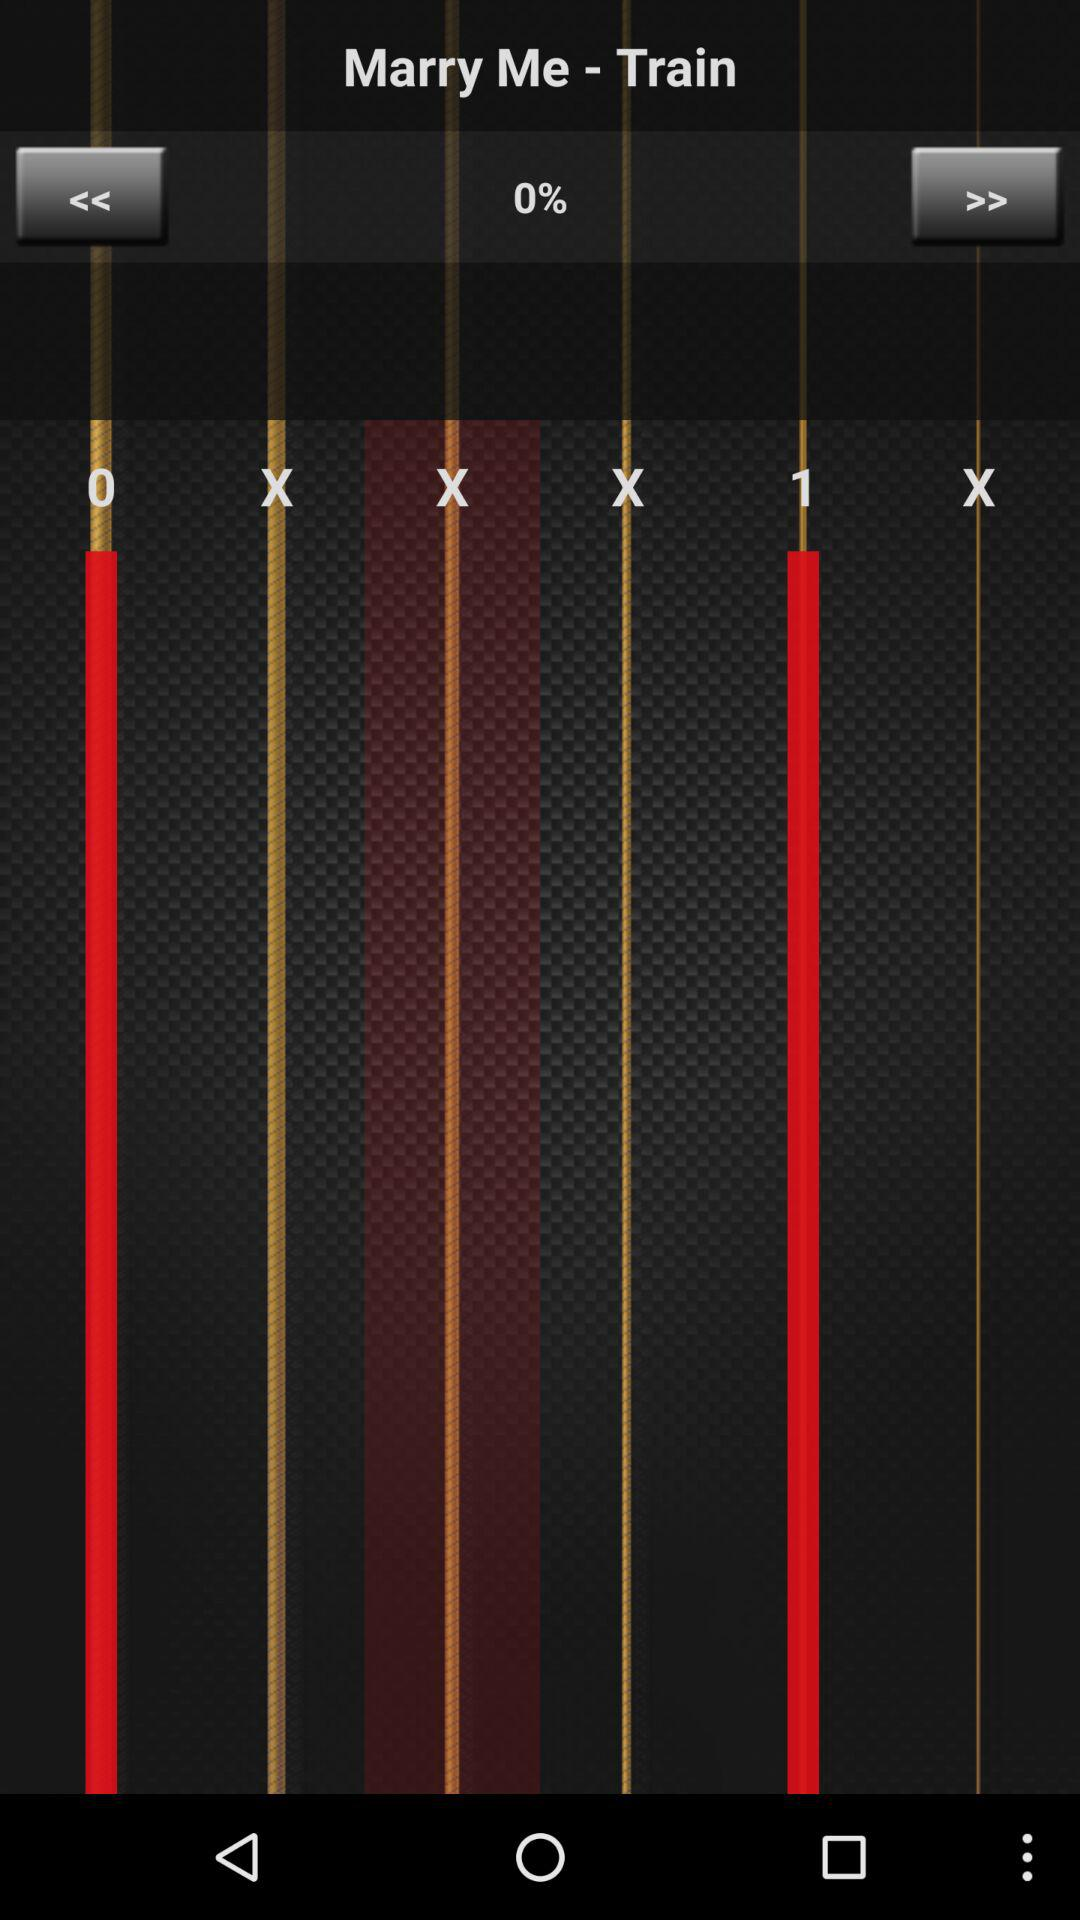What is the difference between the largest and smallest values on the slider?
Answer the question using a single word or phrase. 1 